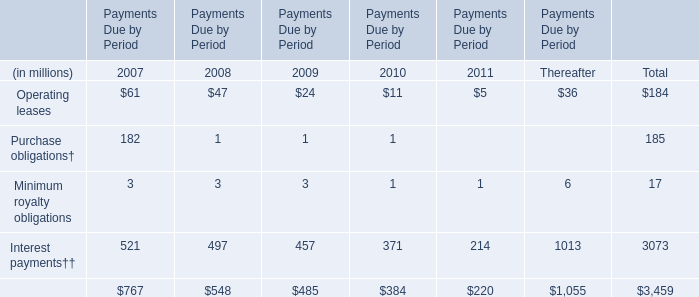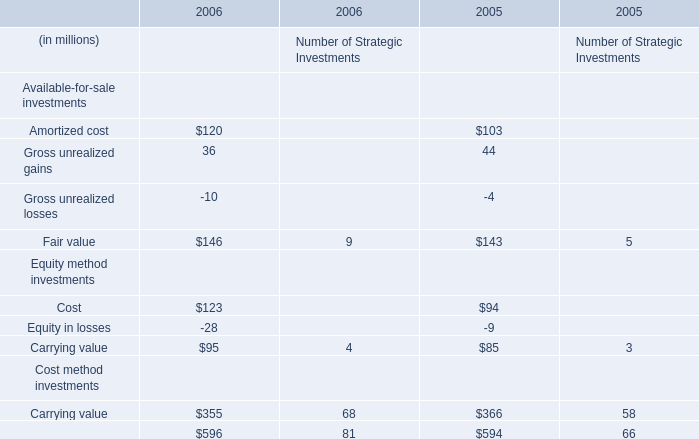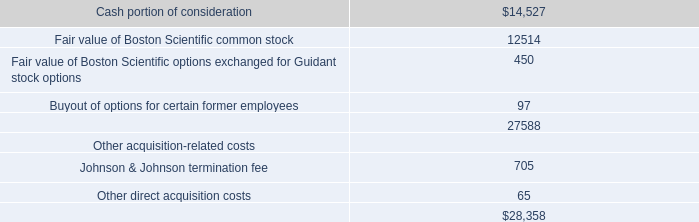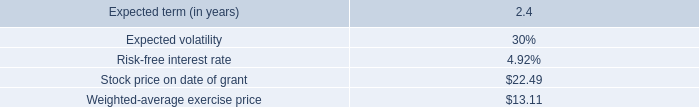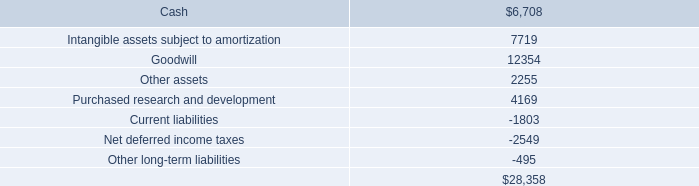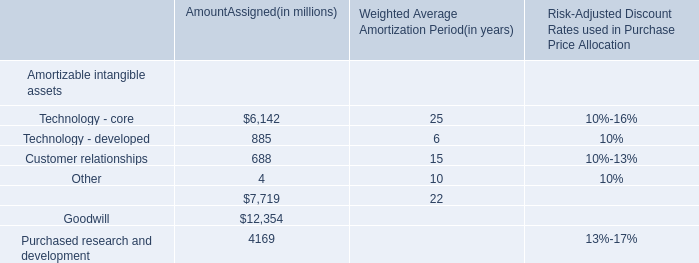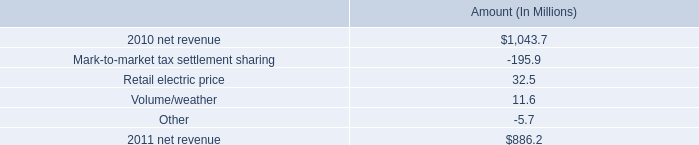What will Amortized cost reach in 2007 if it continues to grow at its 2006 rate? (in million) 
Computations: (120 * (1 + ((120 - 103) / 103)))
Answer: 139.80583. 